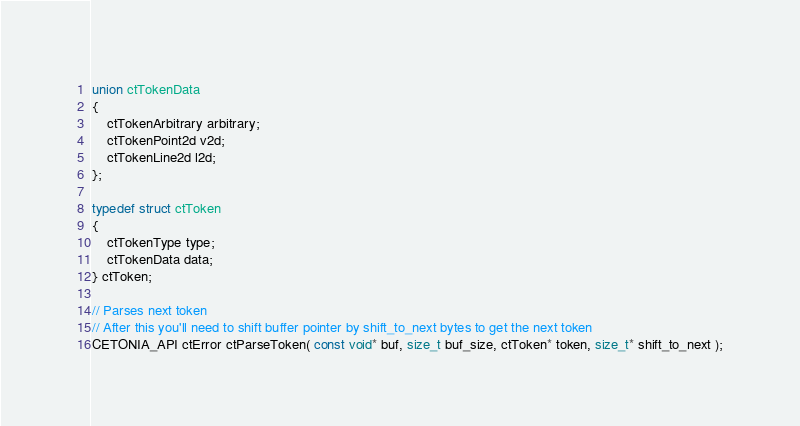Convert code to text. <code><loc_0><loc_0><loc_500><loc_500><_C_>
union ctTokenData
{
	ctTokenArbitrary arbitrary;
	ctTokenPoint2d v2d;
	ctTokenLine2d l2d;
};

typedef struct ctToken
{
	ctTokenType type;
	ctTokenData data;
} ctToken;

// Parses next token
// After this you'll need to shift buffer pointer by shift_to_next bytes to get the next token
CETONIA_API ctError ctParseToken( const void* buf, size_t buf_size, ctToken* token, size_t* shift_to_next );</code> 